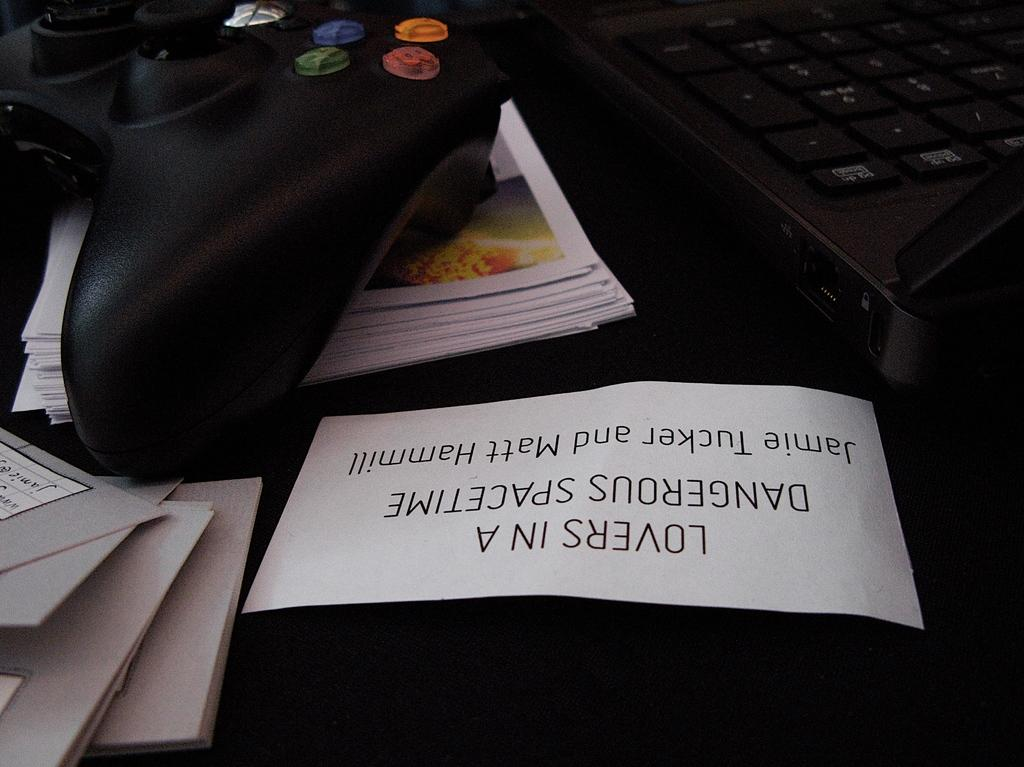Provide a one-sentence caption for the provided image. A video controller sits alongside a sign that reads lovers in a dangerous spacetime. 